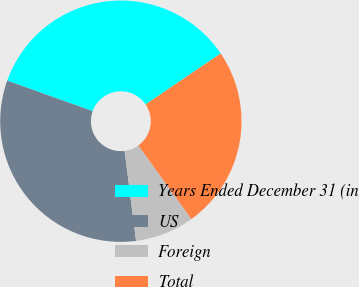Convert chart. <chart><loc_0><loc_0><loc_500><loc_500><pie_chart><fcel>Years Ended December 31 (in<fcel>US<fcel>Foreign<fcel>Total<nl><fcel>35.06%<fcel>32.47%<fcel>7.93%<fcel>24.54%<nl></chart> 